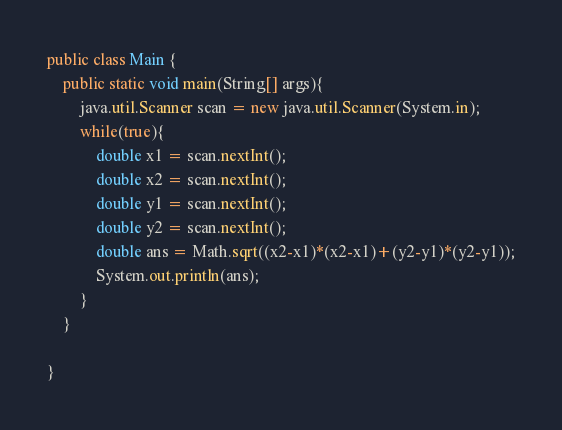<code> <loc_0><loc_0><loc_500><loc_500><_Java_>public class Main {
	public static void main(String[] args){
		java.util.Scanner scan = new java.util.Scanner(System.in);
		while(true){
			double x1 = scan.nextInt();
			double x2 = scan.nextInt();
			double y1 = scan.nextInt();
			double y2 = scan.nextInt();
			double ans = Math.sqrt((x2-x1)*(x2-x1)+(y2-y1)*(y2-y1));
			System.out.println(ans);
		}
	}

}</code> 